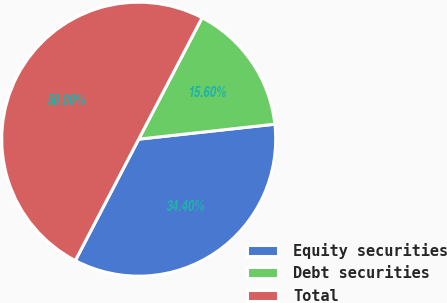Convert chart. <chart><loc_0><loc_0><loc_500><loc_500><pie_chart><fcel>Equity securities<fcel>Debt securities<fcel>Total<nl><fcel>34.4%<fcel>15.6%<fcel>50.0%<nl></chart> 